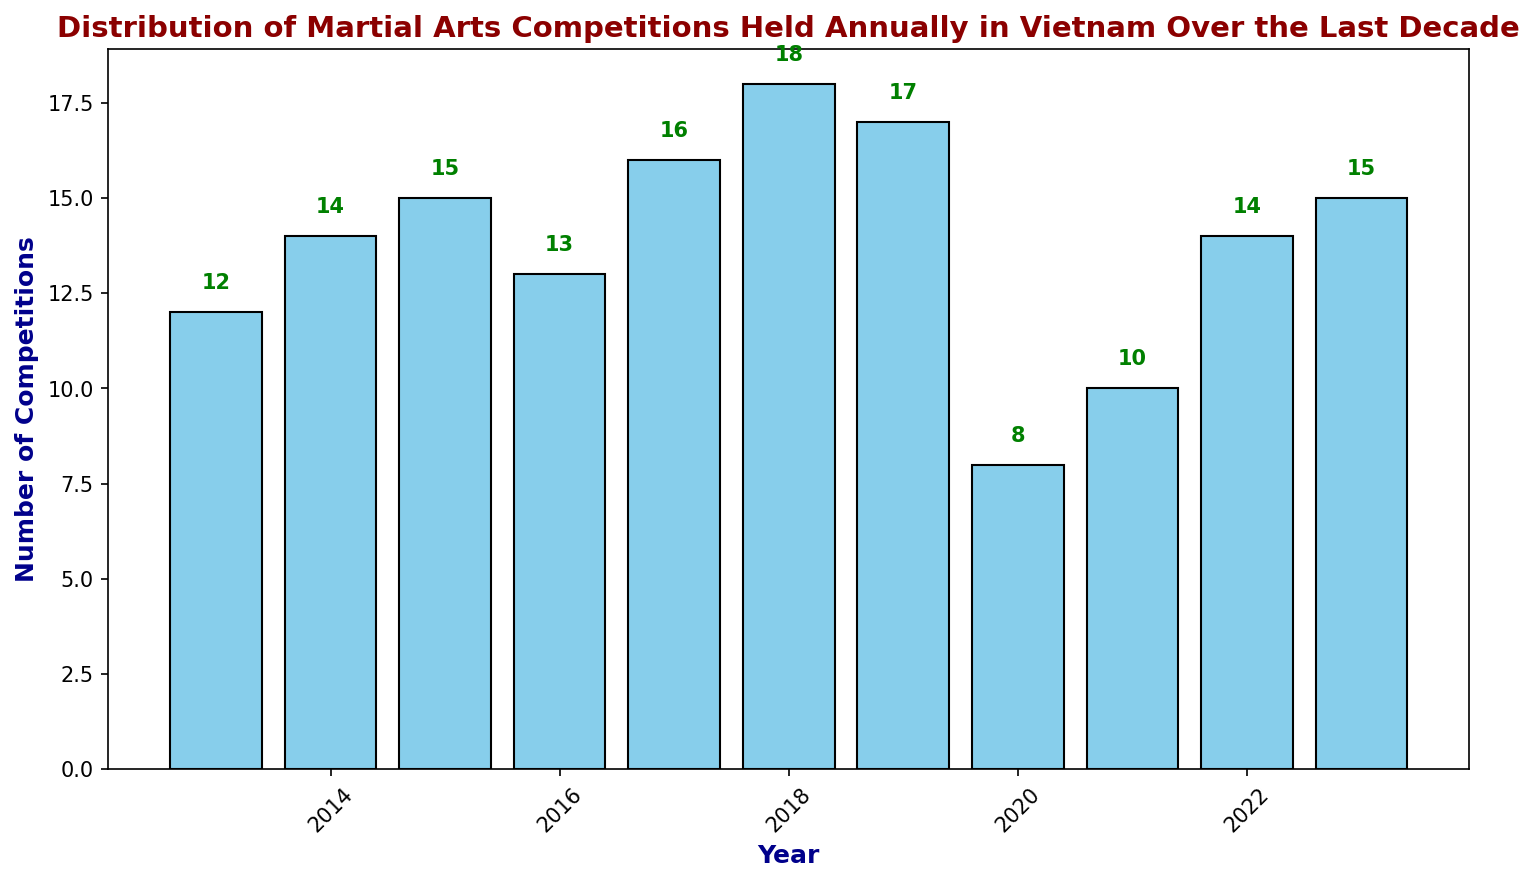What was the total number of martial arts competitions in 2020 and 2021 combined? Look at the bar heights for years 2020 and 2021. In 2020, there were 8 competitions, and in 2021, there were 10 competitions. Adding them together gives 8 + 10 = 18.
Answer: 18 Which year had the highest number of martial arts competitions? Identify the tallest bar on the plot. The year that had the highest number of competitions is 2018 with 18 competitions.
Answer: 2018 How many years had fewer than 12 competitions? Count the number of bars whose heights are below 12. The years 2013, 2020, and 2021 had fewer than 12 competitions. So, there are 3 years in total.
Answer: 3 In which year did the number of competitions decrease the most compared to the previous year? Examine the height differences between consecutive years. The largest drop occurred between 2019 (17 competitions) and 2020 (8 competitions), resulting in a decrease of 17 - 8 = 9 competitions.
Answer: 2020 What's the average number of competitions held annually over the decade? Add up the number of competitions for each year and divide by the number of years. The sum is 12 + 14 + 15 + 13 + 16 + 18 + 17 + 8 + 10 + 14 + 15 = 152. Dividing by 11 years gives 152 / 11 ≈ 13.82.
Answer: 13.82 Which year had more competitions, 2014 or 2023? Compare the heights of the bars for the years 2014 and 2023. 2014 had 14 competitions, while 2023 had 15 competitions. Hence, 2023 had more competitions.
Answer: 2023 What is the difference in the number of competitions between the years with the highest and lowest competitions? Find the difference between the highest and the lowest bars. The highest is 2018 with 18 competitions, and the lowest is 2020 with 8 competitions. The difference is 18 - 8 = 10.
Answer: 10 How many competitions were held in the years 2016 and 2017 combined? Look at the bar heights for years 2016 and 2017. There were 13 competitions in 2016 and 16 in 2017. Adding them together gives 13 + 16 = 29.
Answer: 29 Is the number of competitions in 2019 higher or lower compared to 2018? Compare the heights of the bars for the years 2018 and 2019. 2018 had 18 competitions, while 2019 had 17 competitions. Hence, 2019 had fewer competitions.
Answer: Lower 